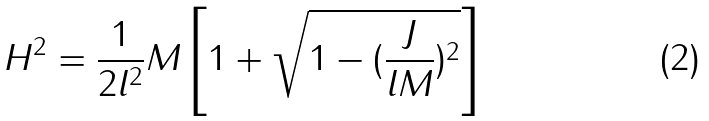Convert formula to latex. <formula><loc_0><loc_0><loc_500><loc_500>H ^ { 2 } = \frac { 1 } { 2 l ^ { 2 } } M \left [ 1 + \sqrt { 1 - ( \frac { J } { l M } ) ^ { 2 } } \right ]</formula> 